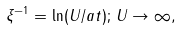Convert formula to latex. <formula><loc_0><loc_0><loc_500><loc_500>\xi ^ { - 1 } = \ln ( U / a t ) ; \, U \rightarrow \infty ,</formula> 